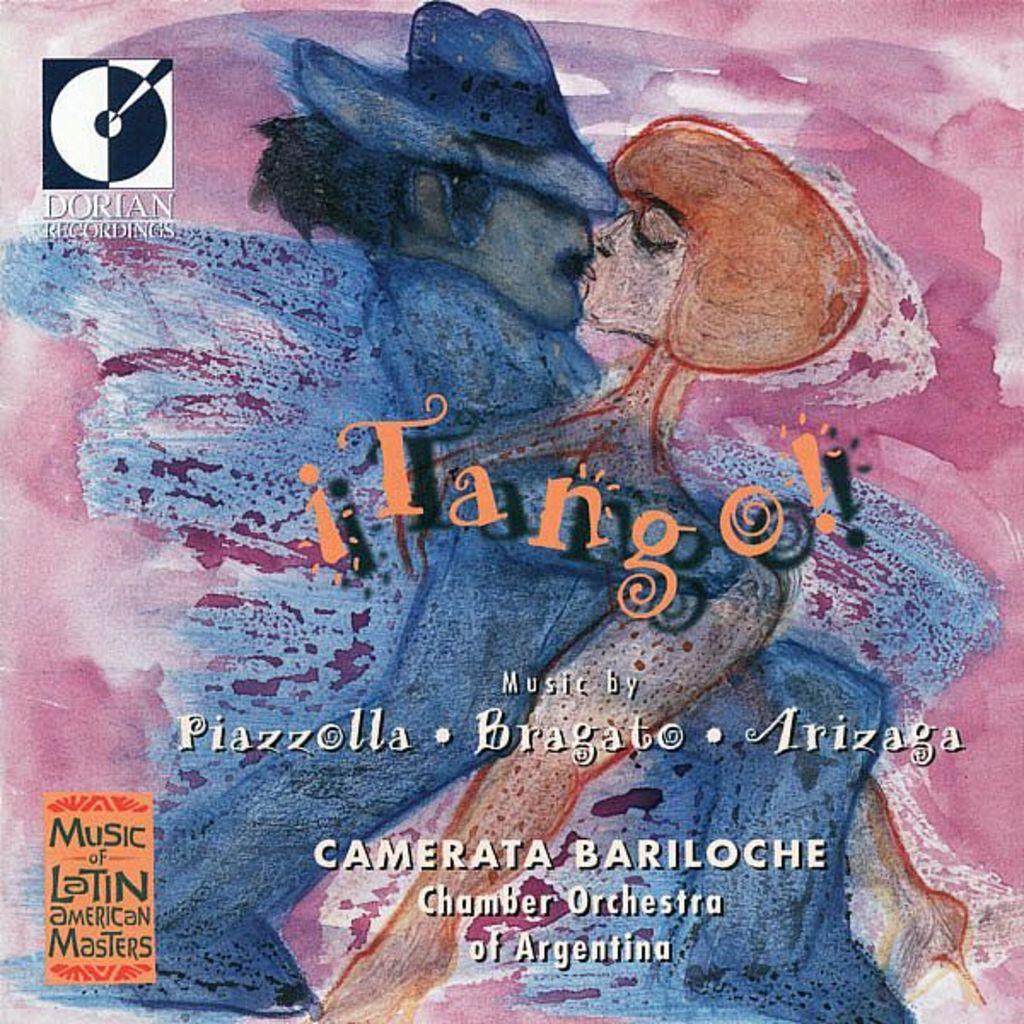What country's orchestra is featured?
Make the answer very short. Argentina. Who is the music by?
Your answer should be very brief. Piazzolla. 